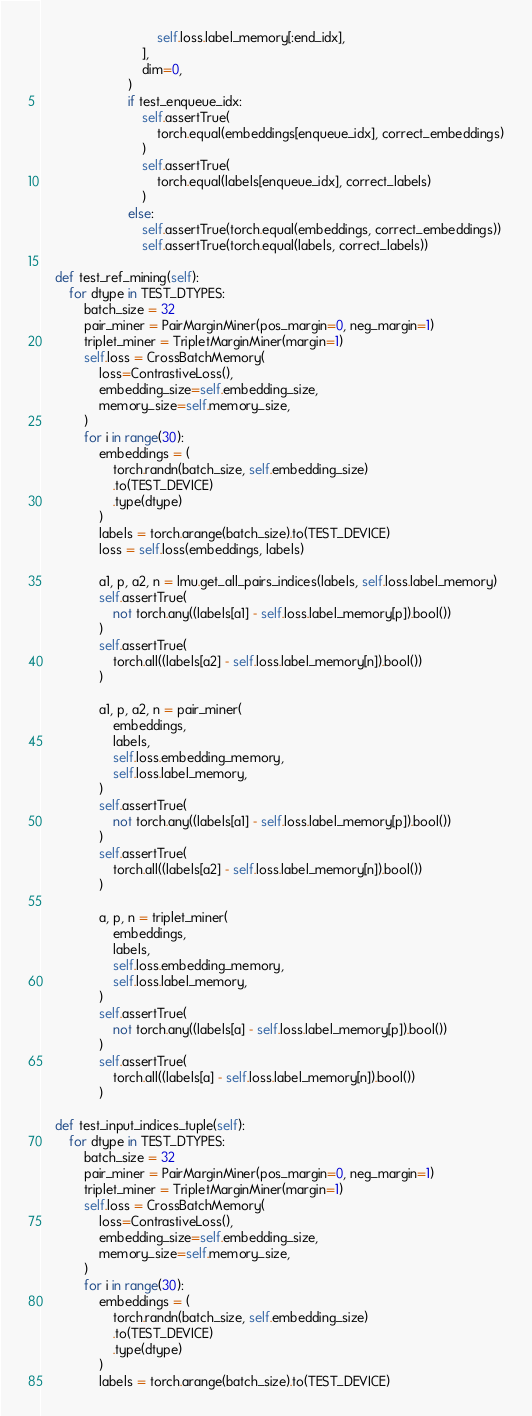Convert code to text. <code><loc_0><loc_0><loc_500><loc_500><_Python_>                                self.loss.label_memory[:end_idx],
                            ],
                            dim=0,
                        )
                        if test_enqueue_idx:
                            self.assertTrue(
                                torch.equal(embeddings[enqueue_idx], correct_embeddings)
                            )
                            self.assertTrue(
                                torch.equal(labels[enqueue_idx], correct_labels)
                            )
                        else:
                            self.assertTrue(torch.equal(embeddings, correct_embeddings))
                            self.assertTrue(torch.equal(labels, correct_labels))

    def test_ref_mining(self):
        for dtype in TEST_DTYPES:
            batch_size = 32
            pair_miner = PairMarginMiner(pos_margin=0, neg_margin=1)
            triplet_miner = TripletMarginMiner(margin=1)
            self.loss = CrossBatchMemory(
                loss=ContrastiveLoss(),
                embedding_size=self.embedding_size,
                memory_size=self.memory_size,
            )
            for i in range(30):
                embeddings = (
                    torch.randn(batch_size, self.embedding_size)
                    .to(TEST_DEVICE)
                    .type(dtype)
                )
                labels = torch.arange(batch_size).to(TEST_DEVICE)
                loss = self.loss(embeddings, labels)

                a1, p, a2, n = lmu.get_all_pairs_indices(labels, self.loss.label_memory)
                self.assertTrue(
                    not torch.any((labels[a1] - self.loss.label_memory[p]).bool())
                )
                self.assertTrue(
                    torch.all((labels[a2] - self.loss.label_memory[n]).bool())
                )

                a1, p, a2, n = pair_miner(
                    embeddings,
                    labels,
                    self.loss.embedding_memory,
                    self.loss.label_memory,
                )
                self.assertTrue(
                    not torch.any((labels[a1] - self.loss.label_memory[p]).bool())
                )
                self.assertTrue(
                    torch.all((labels[a2] - self.loss.label_memory[n]).bool())
                )

                a, p, n = triplet_miner(
                    embeddings,
                    labels,
                    self.loss.embedding_memory,
                    self.loss.label_memory,
                )
                self.assertTrue(
                    not torch.any((labels[a] - self.loss.label_memory[p]).bool())
                )
                self.assertTrue(
                    torch.all((labels[a] - self.loss.label_memory[n]).bool())
                )

    def test_input_indices_tuple(self):
        for dtype in TEST_DTYPES:
            batch_size = 32
            pair_miner = PairMarginMiner(pos_margin=0, neg_margin=1)
            triplet_miner = TripletMarginMiner(margin=1)
            self.loss = CrossBatchMemory(
                loss=ContrastiveLoss(),
                embedding_size=self.embedding_size,
                memory_size=self.memory_size,
            )
            for i in range(30):
                embeddings = (
                    torch.randn(batch_size, self.embedding_size)
                    .to(TEST_DEVICE)
                    .type(dtype)
                )
                labels = torch.arange(batch_size).to(TEST_DEVICE)</code> 